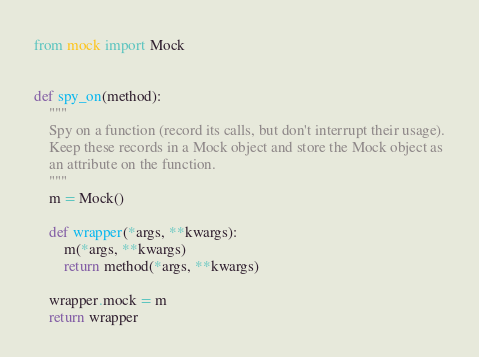<code> <loc_0><loc_0><loc_500><loc_500><_Python_>from mock import Mock


def spy_on(method):
    """
    Spy on a function (record its calls, but don't interrupt their usage).
    Keep these records in a Mock object and store the Mock object as
    an attribute on the function.
    """
    m = Mock()

    def wrapper(*args, **kwargs):
        m(*args, **kwargs)
        return method(*args, **kwargs)

    wrapper.mock = m
    return wrapper
</code> 